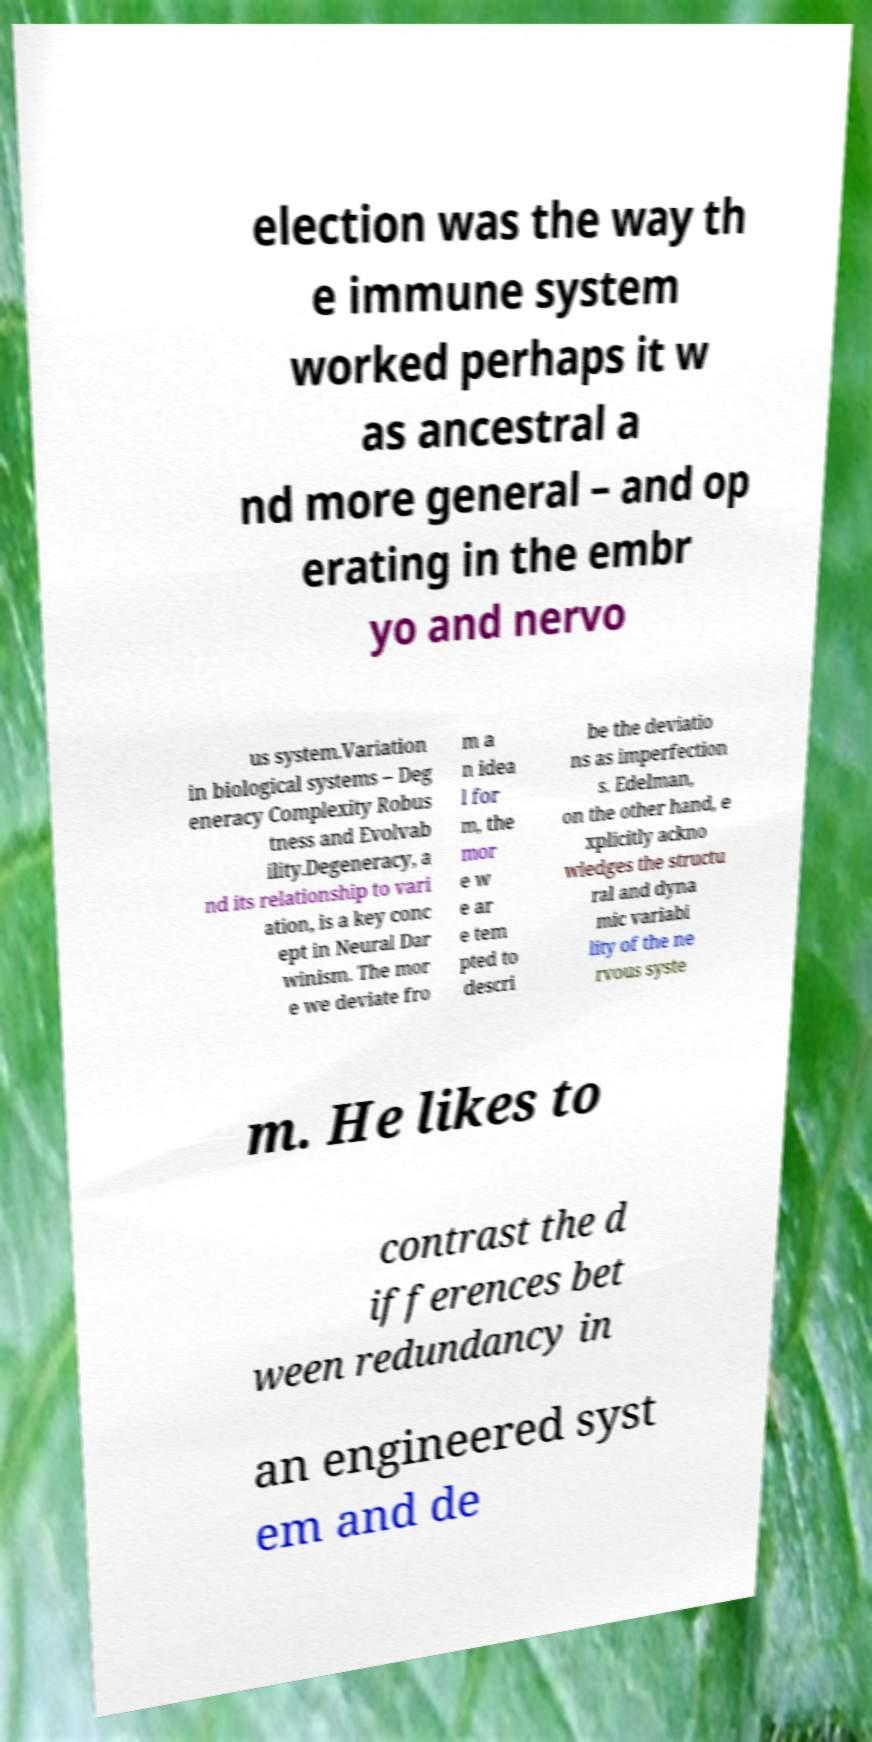There's text embedded in this image that I need extracted. Can you transcribe it verbatim? election was the way th e immune system worked perhaps it w as ancestral a nd more general – and op erating in the embr yo and nervo us system.Variation in biological systems – Deg eneracy Complexity Robus tness and Evolvab ility.Degeneracy, a nd its relationship to vari ation, is a key conc ept in Neural Dar winism. The mor e we deviate fro m a n idea l for m, the mor e w e ar e tem pted to descri be the deviatio ns as imperfection s. Edelman, on the other hand, e xplicitly ackno wledges the structu ral and dyna mic variabi lity of the ne rvous syste m. He likes to contrast the d ifferences bet ween redundancy in an engineered syst em and de 